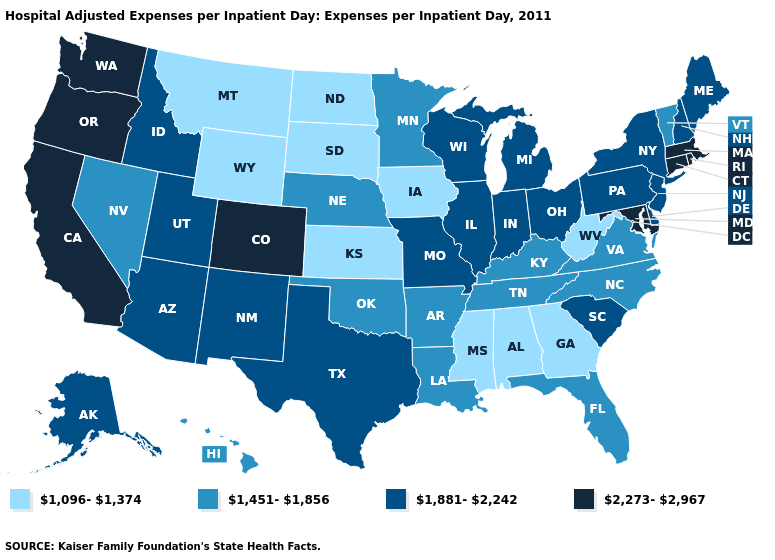What is the value of South Dakota?
Quick response, please. 1,096-1,374. What is the value of Virginia?
Give a very brief answer. 1,451-1,856. What is the highest value in the USA?
Write a very short answer. 2,273-2,967. What is the value of North Carolina?
Write a very short answer. 1,451-1,856. Does the map have missing data?
Short answer required. No. Does Illinois have a higher value than Nebraska?
Concise answer only. Yes. Does the map have missing data?
Write a very short answer. No. Which states hav the highest value in the West?
Concise answer only. California, Colorado, Oregon, Washington. Name the states that have a value in the range 1,451-1,856?
Concise answer only. Arkansas, Florida, Hawaii, Kentucky, Louisiana, Minnesota, Nebraska, Nevada, North Carolina, Oklahoma, Tennessee, Vermont, Virginia. What is the lowest value in the USA?
Keep it brief. 1,096-1,374. How many symbols are there in the legend?
Short answer required. 4. Name the states that have a value in the range 1,096-1,374?
Write a very short answer. Alabama, Georgia, Iowa, Kansas, Mississippi, Montana, North Dakota, South Dakota, West Virginia, Wyoming. Among the states that border North Dakota , does Minnesota have the lowest value?
Concise answer only. No. Does New Hampshire have a higher value than Indiana?
Short answer required. No. What is the value of New Mexico?
Keep it brief. 1,881-2,242. 